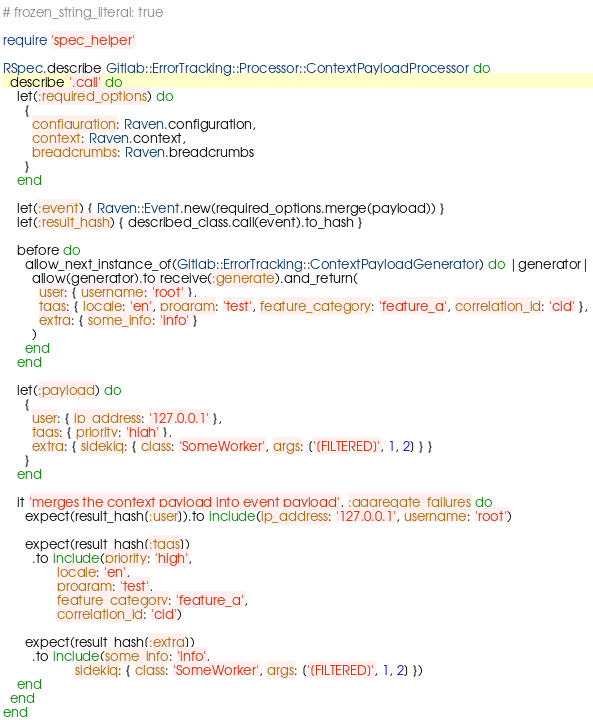Convert code to text. <code><loc_0><loc_0><loc_500><loc_500><_Ruby_># frozen_string_literal: true

require 'spec_helper'

RSpec.describe Gitlab::ErrorTracking::Processor::ContextPayloadProcessor do
  describe '.call' do
    let(:required_options) do
      {
        configuration: Raven.configuration,
        context: Raven.context,
        breadcrumbs: Raven.breadcrumbs
      }
    end

    let(:event) { Raven::Event.new(required_options.merge(payload)) }
    let(:result_hash) { described_class.call(event).to_hash }

    before do
      allow_next_instance_of(Gitlab::ErrorTracking::ContextPayloadGenerator) do |generator|
        allow(generator).to receive(:generate).and_return(
          user: { username: 'root' },
          tags: { locale: 'en', program: 'test', feature_category: 'feature_a', correlation_id: 'cid' },
          extra: { some_info: 'info' }
        )
      end
    end

    let(:payload) do
      {
        user: { ip_address: '127.0.0.1' },
        tags: { priority: 'high' },
        extra: { sidekiq: { class: 'SomeWorker', args: ['[FILTERED]', 1, 2] } }
      }
    end

    it 'merges the context payload into event payload', :aggregate_failures do
      expect(result_hash[:user]).to include(ip_address: '127.0.0.1', username: 'root')

      expect(result_hash[:tags])
        .to include(priority: 'high',
               locale: 'en',
               program: 'test',
               feature_category: 'feature_a',
               correlation_id: 'cid')

      expect(result_hash[:extra])
        .to include(some_info: 'info',
                    sidekiq: { class: 'SomeWorker', args: ['[FILTERED]', 1, 2] })
    end
  end
end
</code> 